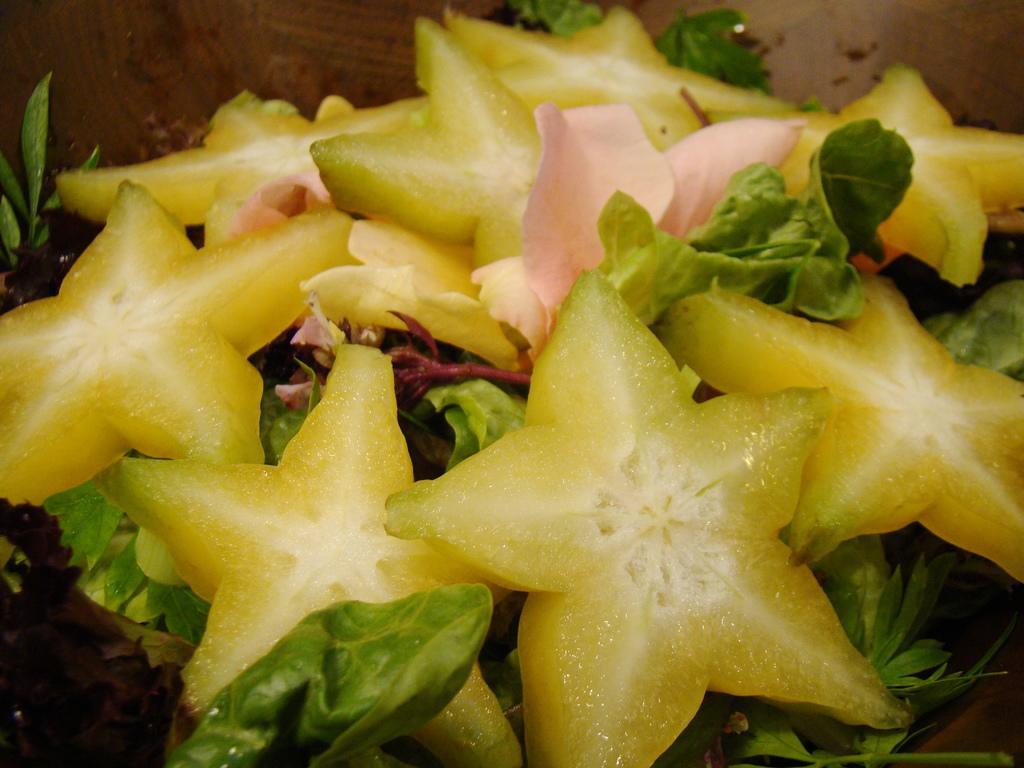Can you describe this image briefly? This picture contains star fruits and leafy vegetables. In the background, it is brown in color. 